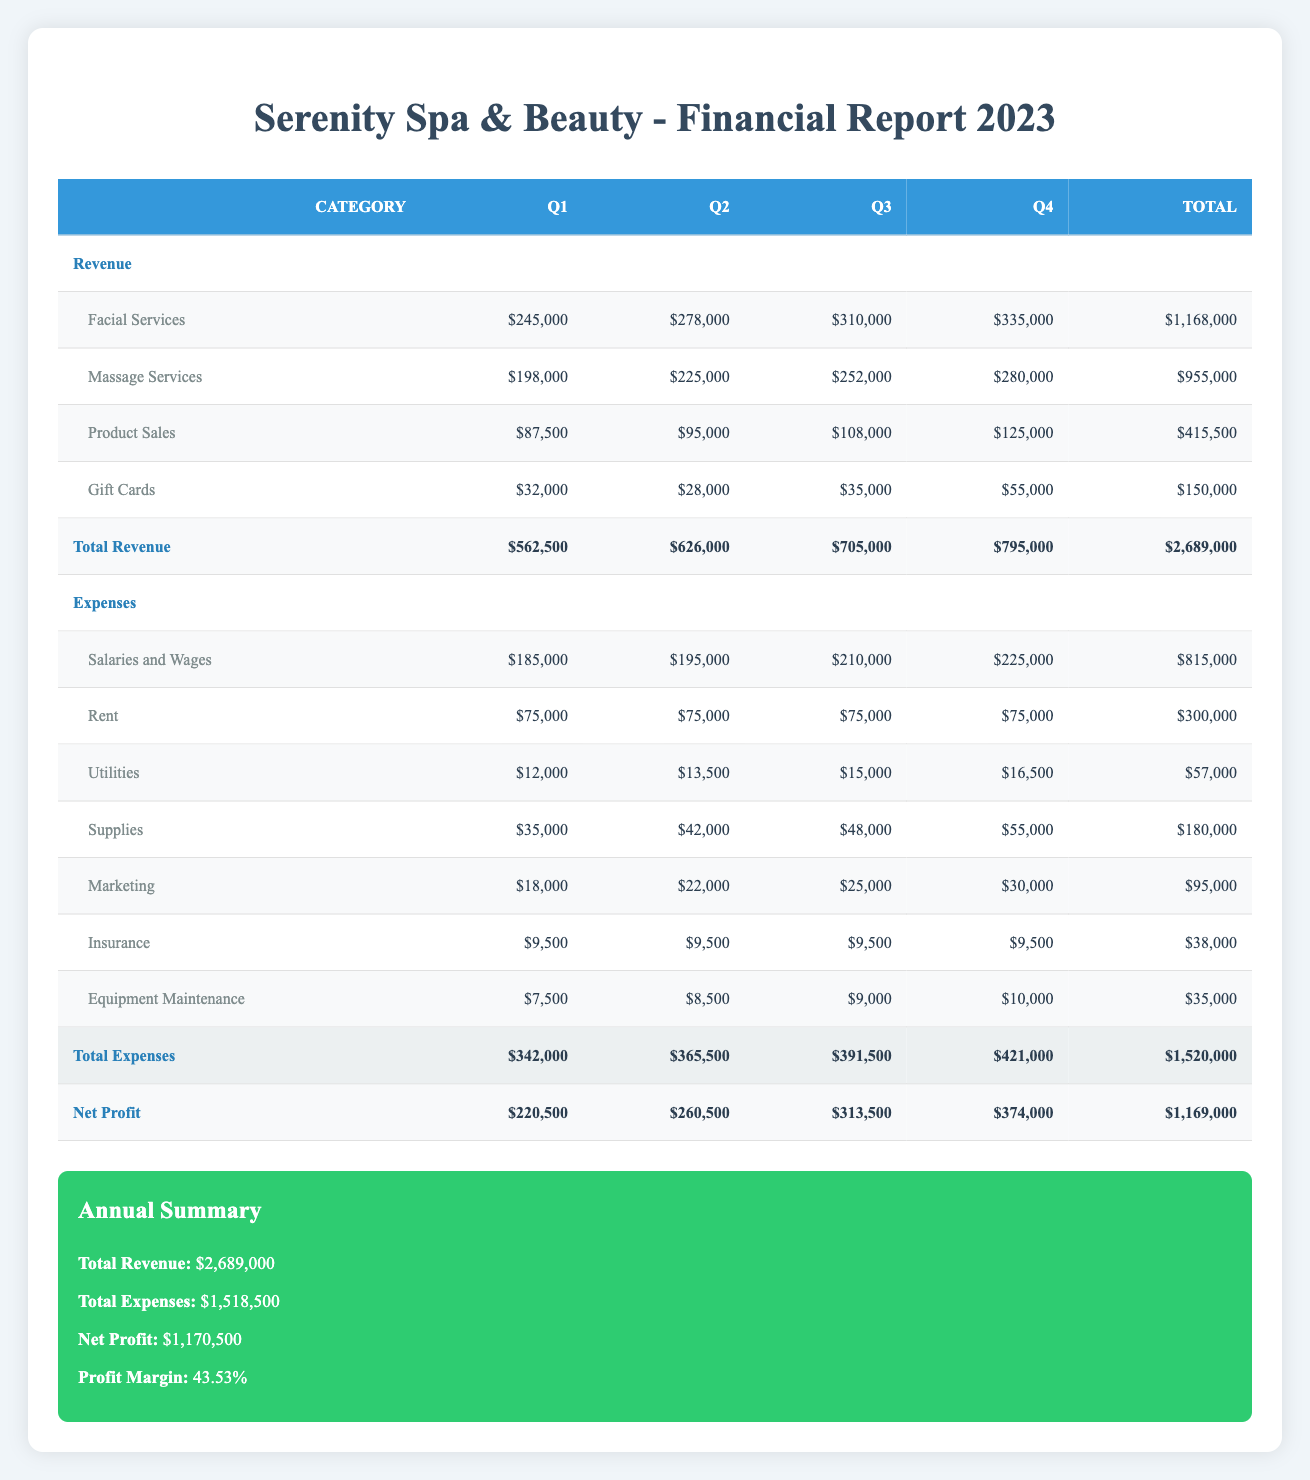What was the total revenue from facial services in 2023? To find the total revenue from facial services, we sum the values from each quarter: 245,000 (Q1) + 278,000 (Q2) + 310,000 (Q3) + 335,000 (Q4) = 1,168,000.
Answer: 1,168,000 What was the highest expense category in Q4? From the expenses listed for Q4, the expenses were: salaries and wages (225,000), rent (75,000), utilities (16,500), supplies (55,000), marketing (30,000), insurance (9,500), and equipment maintenance (10,000). The highest is salaries and wages at 225,000.
Answer: Salaries and wages Was the total net profit higher in Q3 or Q4? The net profits for Q3 and Q4 are 313,500 and 374,000 respectively. Since 374,000 is greater than 313,500, net profit was higher in Q4 than in Q3.
Answer: Yes, it was higher in Q4 What was the average marketing cost per quarter for 2023? The marketing costs were: 18,000 (Q1) + 22,000 (Q2) + 25,000 (Q3) + 30,000 (Q4) = 95,000. Dividing this total by 4 (the number of quarters) gives 95,000 / 4 = 23,750.
Answer: 23,750 Did the total revenue in Q2 exceed that of Q1? The total revenue for Q2 was 626,000, while for Q1 it was 562,500. Since 626,000 is greater than 562,500, the statement is true.
Answer: Yes Which quarter had the lowest total expenses? The total expenses for each quarter were: 342,000 (Q1), 365,500 (Q2), 391,500 (Q3), and 421,000 (Q4). The lowest is 342,000 in Q1.
Answer: Q1 How much did the total gift card sales contribute to the revenue for 2023? The gift card sales for the quarters were: 32,000 (Q1), 28,000 (Q2), 35,000 (Q3), and 55,000 (Q4). Summing these gives 32,000 + 28,000 + 35,000 + 55,000 = 150,000.
Answer: 150,000 What is the profit margin for the salon in 2023? The profit margin is calculated using the formula: (Net Profit / Total Revenue) * 100. The net profit is 1,170,500, and total revenue is 2,689,000. Thus, (1,170,500 / 2,689,000) * 100 ≈ 43.53%.
Answer: 43.53% 